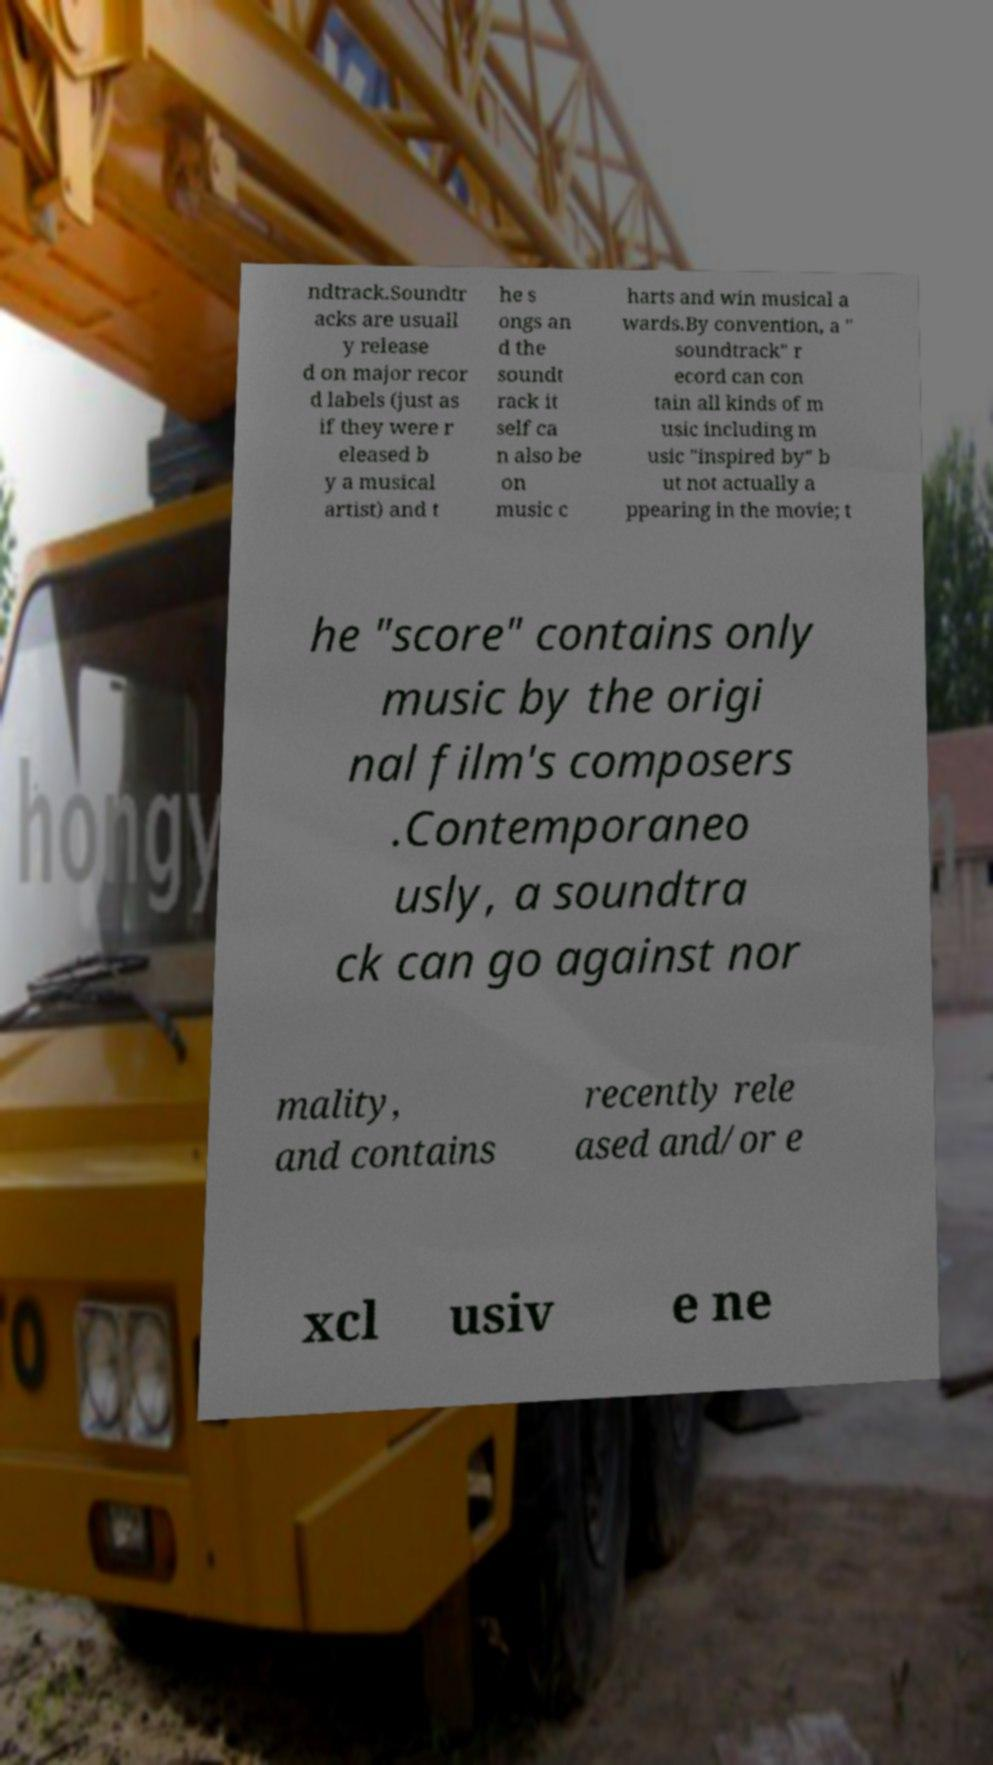Please identify and transcribe the text found in this image. ndtrack.Soundtr acks are usuall y release d on major recor d labels (just as if they were r eleased b y a musical artist) and t he s ongs an d the soundt rack it self ca n also be on music c harts and win musical a wards.By convention, a " soundtrack" r ecord can con tain all kinds of m usic including m usic "inspired by" b ut not actually a ppearing in the movie; t he "score" contains only music by the origi nal film's composers .Contemporaneo usly, a soundtra ck can go against nor mality, and contains recently rele ased and/or e xcl usiv e ne 